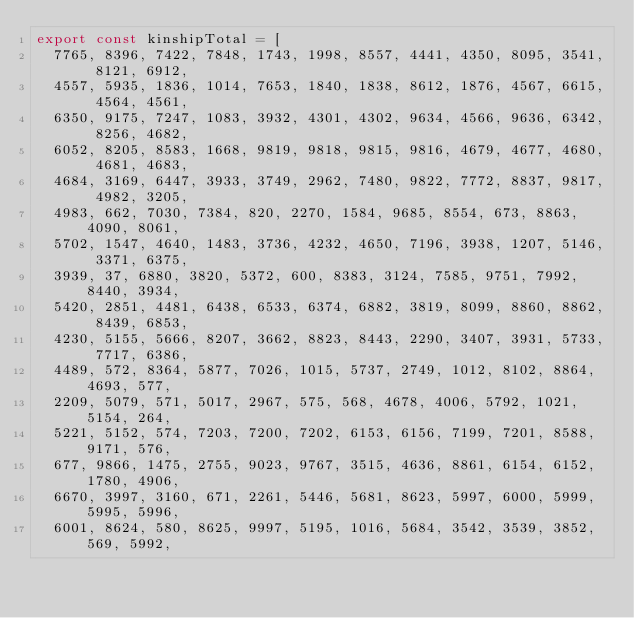<code> <loc_0><loc_0><loc_500><loc_500><_TypeScript_>export const kinshipTotal = [
  7765, 8396, 7422, 7848, 1743, 1998, 8557, 4441, 4350, 8095, 3541, 8121, 6912,
  4557, 5935, 1836, 1014, 7653, 1840, 1838, 8612, 1876, 4567, 6615, 4564, 4561,
  6350, 9175, 7247, 1083, 3932, 4301, 4302, 9634, 4566, 9636, 6342, 8256, 4682,
  6052, 8205, 8583, 1668, 9819, 9818, 9815, 9816, 4679, 4677, 4680, 4681, 4683,
  4684, 3169, 6447, 3933, 3749, 2962, 7480, 9822, 7772, 8837, 9817, 4982, 3205,
  4983, 662, 7030, 7384, 820, 2270, 1584, 9685, 8554, 673, 8863, 4090, 8061,
  5702, 1547, 4640, 1483, 3736, 4232, 4650, 7196, 3938, 1207, 5146, 3371, 6375,
  3939, 37, 6880, 3820, 5372, 600, 8383, 3124, 7585, 9751, 7992, 8440, 3934,
  5420, 2851, 4481, 6438, 6533, 6374, 6882, 3819, 8099, 8860, 8862, 8439, 6853,
  4230, 5155, 5666, 8207, 3662, 8823, 8443, 2290, 3407, 3931, 5733, 7717, 6386,
  4489, 572, 8364, 5877, 7026, 1015, 5737, 2749, 1012, 8102, 8864, 4693, 577,
  2209, 5079, 571, 5017, 2967, 575, 568, 4678, 4006, 5792, 1021, 5154, 264,
  5221, 5152, 574, 7203, 7200, 7202, 6153, 6156, 7199, 7201, 8588, 9171, 576,
  677, 9866, 1475, 2755, 9023, 9767, 3515, 4636, 8861, 6154, 6152, 1780, 4906,
  6670, 3997, 3160, 671, 2261, 5446, 5681, 8623, 5997, 6000, 5999, 5995, 5996,
  6001, 8624, 580, 8625, 9997, 5195, 1016, 5684, 3542, 3539, 3852, 569, 5992,</code> 